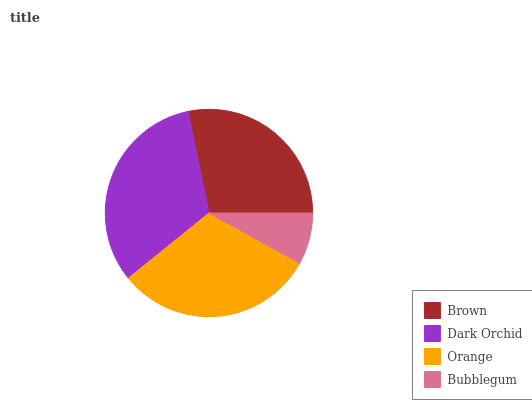Is Bubblegum the minimum?
Answer yes or no. Yes. Is Dark Orchid the maximum?
Answer yes or no. Yes. Is Orange the minimum?
Answer yes or no. No. Is Orange the maximum?
Answer yes or no. No. Is Dark Orchid greater than Orange?
Answer yes or no. Yes. Is Orange less than Dark Orchid?
Answer yes or no. Yes. Is Orange greater than Dark Orchid?
Answer yes or no. No. Is Dark Orchid less than Orange?
Answer yes or no. No. Is Orange the high median?
Answer yes or no. Yes. Is Brown the low median?
Answer yes or no. Yes. Is Brown the high median?
Answer yes or no. No. Is Bubblegum the low median?
Answer yes or no. No. 